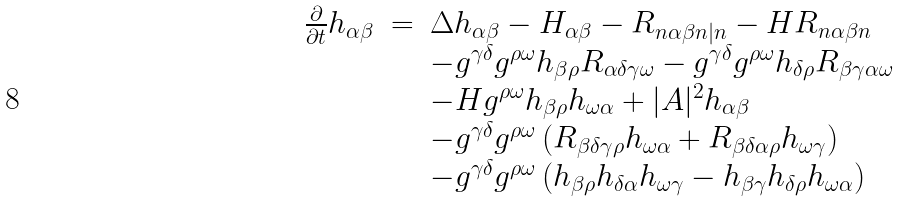Convert formula to latex. <formula><loc_0><loc_0><loc_500><loc_500>\begin{array} { r c l } \frac { \partial } { \partial t } h _ { \alpha \beta } & = & \Delta h _ { \alpha \beta } - H _ { \alpha \beta } - R _ { n \alpha \beta n | n } - H R _ { n \alpha \beta n } \\ & & - g ^ { \gamma \delta } g ^ { \rho \omega } h _ { \beta \rho } R _ { \alpha \delta \gamma \omega } - g ^ { \gamma \delta } g ^ { \rho \omega } h _ { \delta \rho } R _ { \beta \gamma \alpha \omega } \\ & & - H g ^ { \rho \omega } h _ { \beta \rho } h _ { \omega \alpha } + | A | ^ { 2 } h _ { \alpha \beta } \\ & & - g ^ { \gamma \delta } g ^ { \rho \omega } \left ( R _ { \beta \delta \gamma \rho } h _ { \omega \alpha } + R _ { \beta \delta \alpha \rho } h _ { \omega \gamma } \right ) \\ & & - g ^ { \gamma \delta } g ^ { \rho \omega } \left ( h _ { \beta \rho } h _ { \delta \alpha } h _ { \omega \gamma } - h _ { \beta \gamma } h _ { \delta \rho } h _ { \omega \alpha } \right ) \end{array}</formula> 